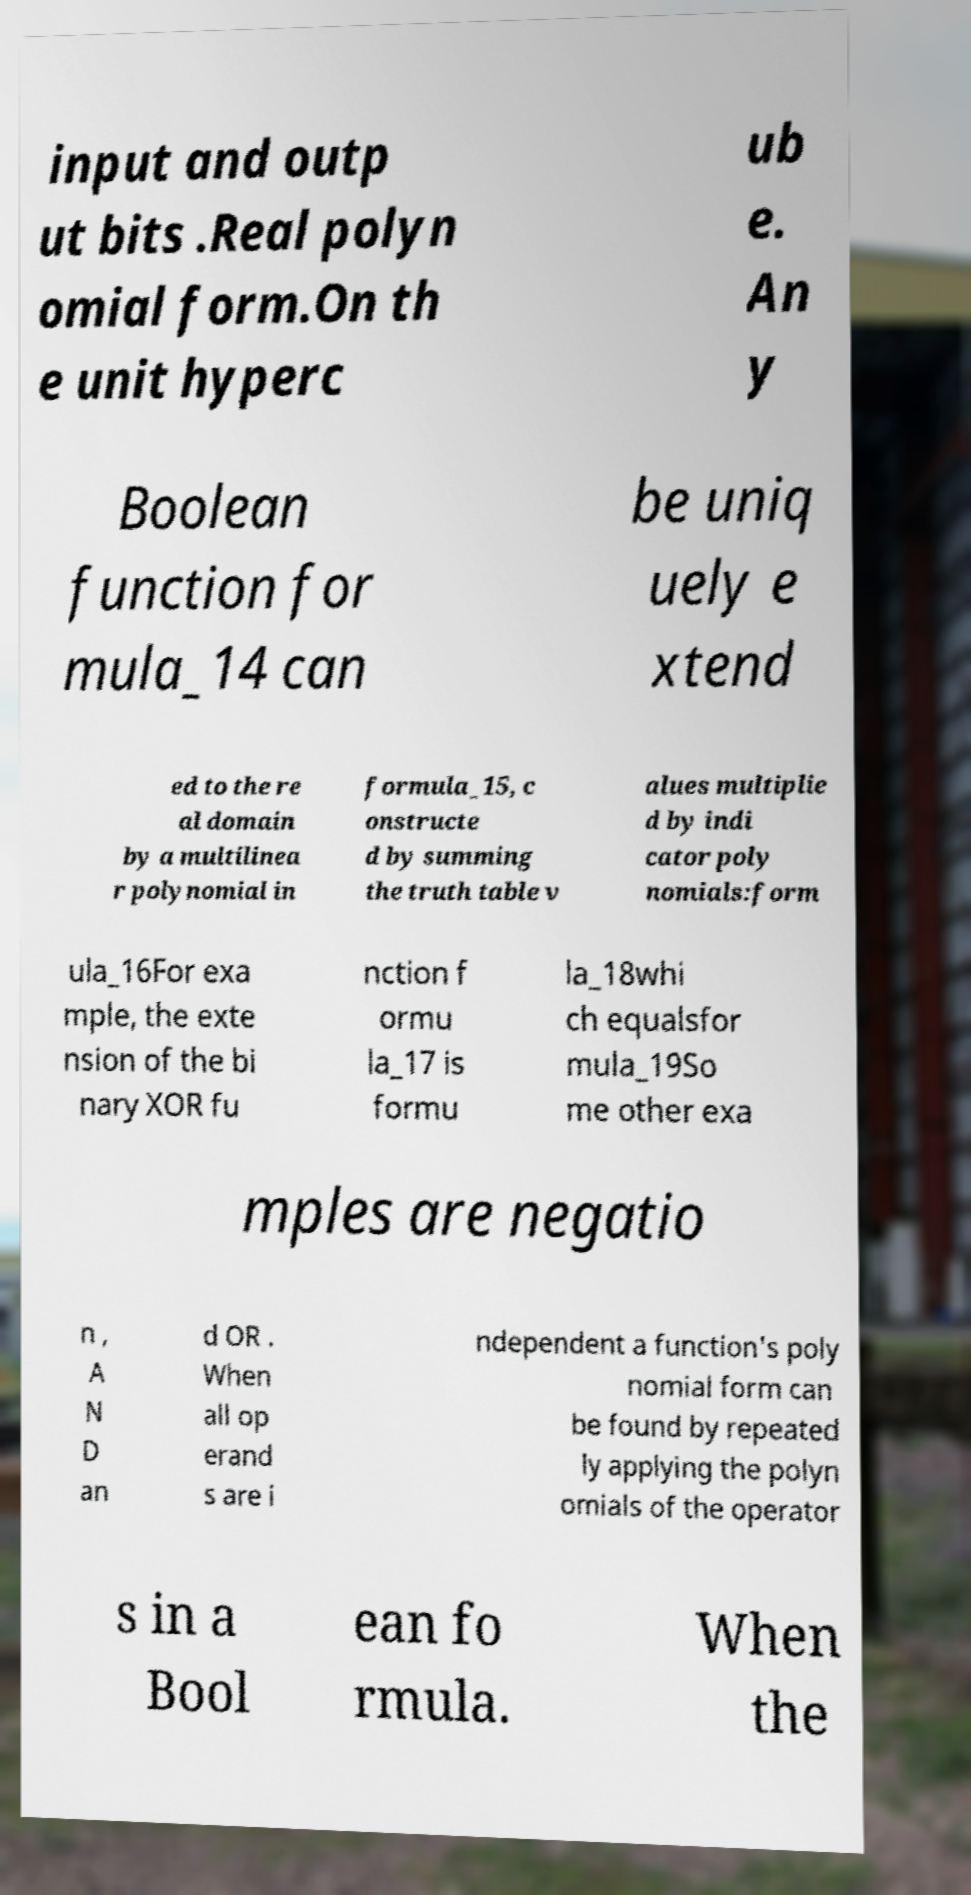There's text embedded in this image that I need extracted. Can you transcribe it verbatim? input and outp ut bits .Real polyn omial form.On th e unit hyperc ub e. An y Boolean function for mula_14 can be uniq uely e xtend ed to the re al domain by a multilinea r polynomial in formula_15, c onstructe d by summing the truth table v alues multiplie d by indi cator poly nomials:form ula_16For exa mple, the exte nsion of the bi nary XOR fu nction f ormu la_17 is formu la_18whi ch equalsfor mula_19So me other exa mples are negatio n , A N D an d OR . When all op erand s are i ndependent a function's poly nomial form can be found by repeated ly applying the polyn omials of the operator s in a Bool ean fo rmula. When the 